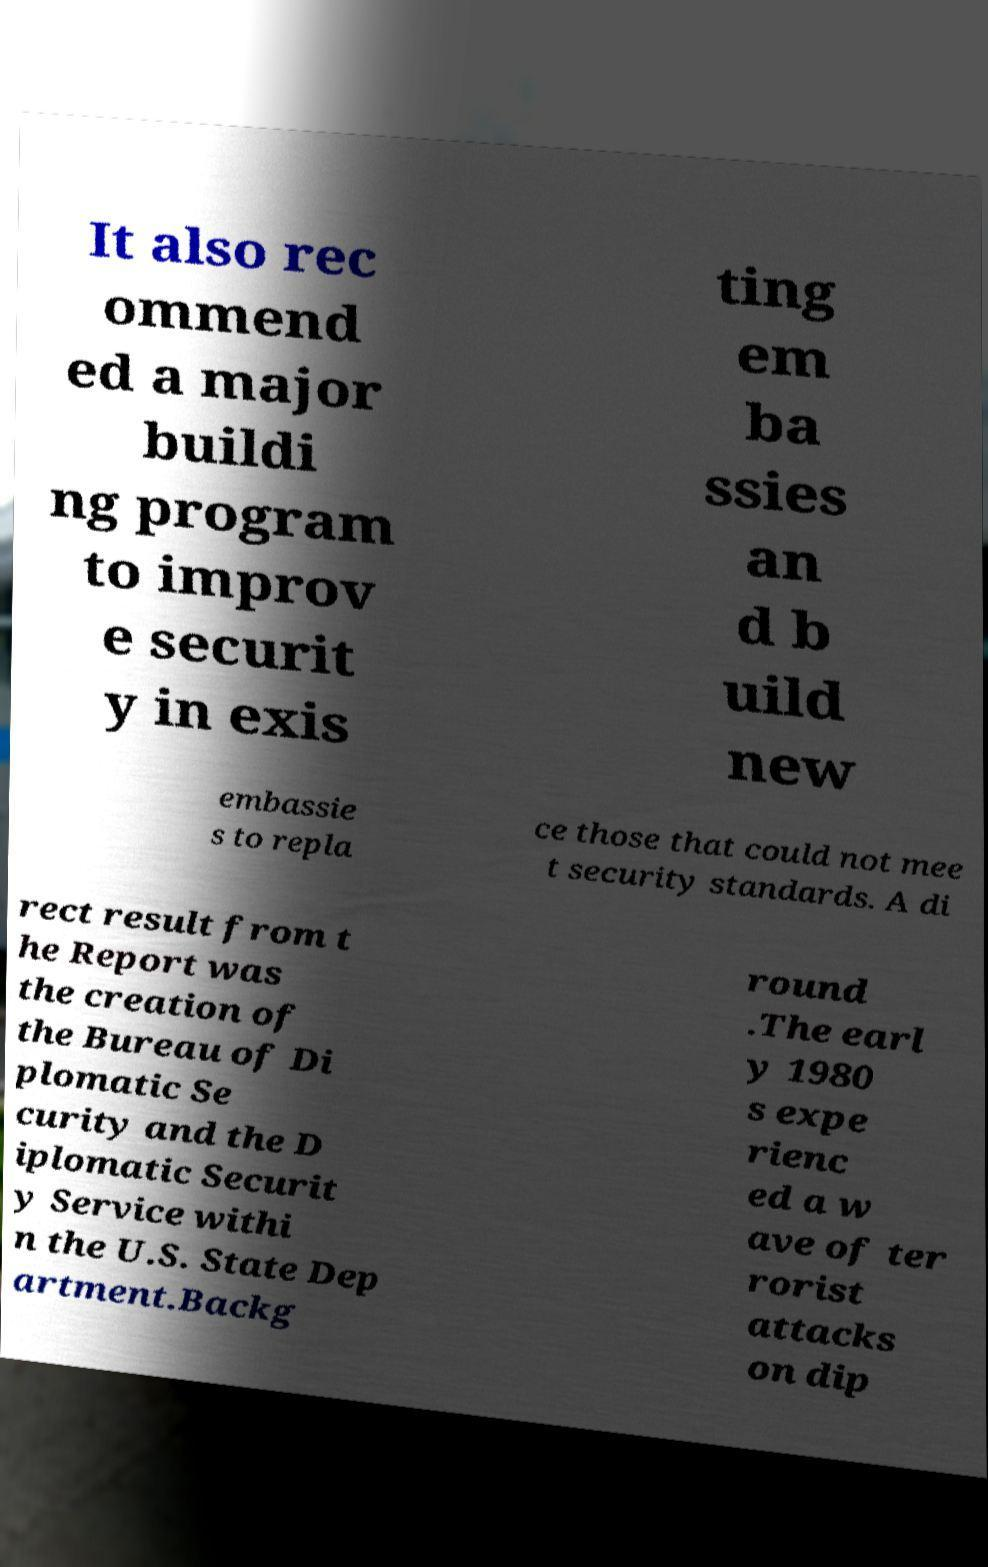There's text embedded in this image that I need extracted. Can you transcribe it verbatim? It also rec ommend ed a major buildi ng program to improv e securit y in exis ting em ba ssies an d b uild new embassie s to repla ce those that could not mee t security standards. A di rect result from t he Report was the creation of the Bureau of Di plomatic Se curity and the D iplomatic Securit y Service withi n the U.S. State Dep artment.Backg round .The earl y 1980 s expe rienc ed a w ave of ter rorist attacks on dip 